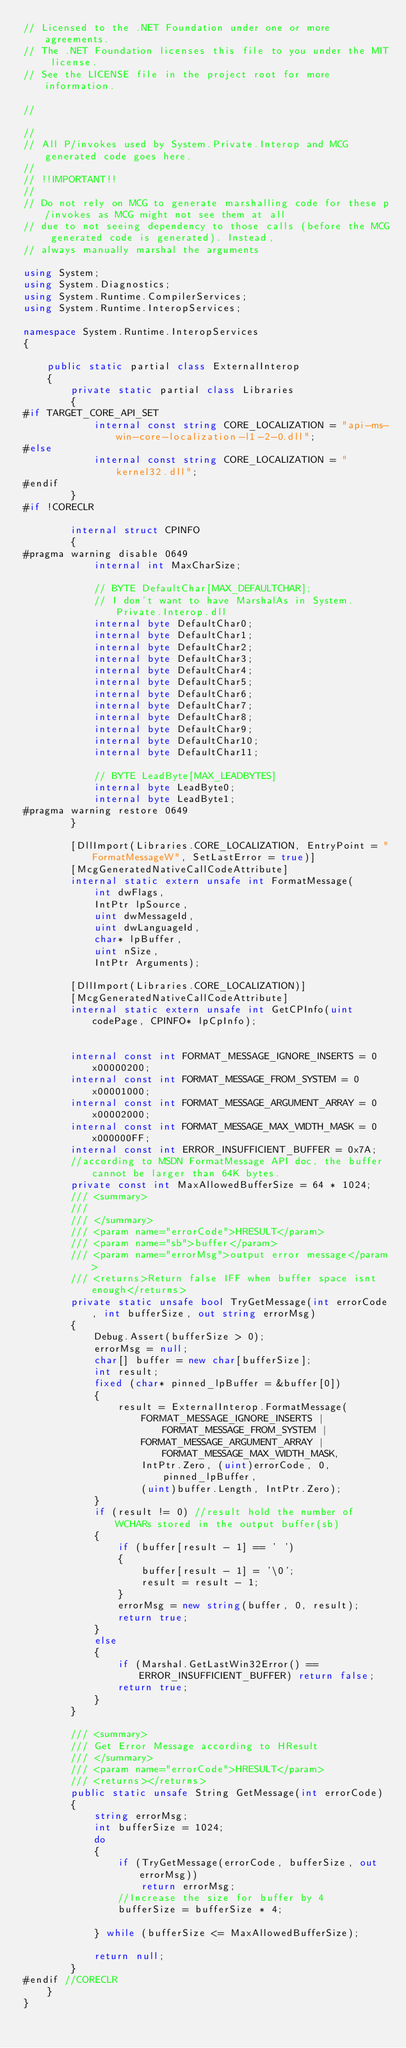Convert code to text. <code><loc_0><loc_0><loc_500><loc_500><_C#_>// Licensed to the .NET Foundation under one or more agreements.
// The .NET Foundation licenses this file to you under the MIT license.
// See the LICENSE file in the project root for more information.

//

//
// All P/invokes used by System.Private.Interop and MCG generated code goes here.
//
// !!IMPORTANT!!
//
// Do not rely on MCG to generate marshalling code for these p/invokes as MCG might not see them at all
// due to not seeing dependency to those calls (before the MCG generated code is generated). Instead,
// always manually marshal the arguments

using System;
using System.Diagnostics;
using System.Runtime.CompilerServices;
using System.Runtime.InteropServices;

namespace System.Runtime.InteropServices
{

    public static partial class ExternalInterop
    {
        private static partial class Libraries
        {
#if TARGET_CORE_API_SET
            internal const string CORE_LOCALIZATION = "api-ms-win-core-localization-l1-2-0.dll";
#else
            internal const string CORE_LOCALIZATION = "kernel32.dll";
#endif
        }
#if !CORECLR

        internal struct CPINFO
        {
#pragma warning disable 0649
            internal int MaxCharSize;

            // BYTE DefaultChar[MAX_DEFAULTCHAR];
            // I don't want to have MarshalAs in System.Private.Interop.dll
            internal byte DefaultChar0;
            internal byte DefaultChar1;
            internal byte DefaultChar2;
            internal byte DefaultChar3;
            internal byte DefaultChar4;
            internal byte DefaultChar5;
            internal byte DefaultChar6;
            internal byte DefaultChar7;
            internal byte DefaultChar8;
            internal byte DefaultChar9;
            internal byte DefaultChar10;
            internal byte DefaultChar11;

            // BYTE LeadByte[MAX_LEADBYTES]
            internal byte LeadByte0;
            internal byte LeadByte1;
#pragma warning restore 0649
        }

        [DllImport(Libraries.CORE_LOCALIZATION, EntryPoint = "FormatMessageW", SetLastError = true)]
        [McgGeneratedNativeCallCodeAttribute]
        internal static extern unsafe int FormatMessage(
            int dwFlags,
            IntPtr lpSource,
            uint dwMessageId,
            uint dwLanguageId,
            char* lpBuffer,
            uint nSize,
            IntPtr Arguments);

        [DllImport(Libraries.CORE_LOCALIZATION)]
        [McgGeneratedNativeCallCodeAttribute]
        internal static extern unsafe int GetCPInfo(uint codePage, CPINFO* lpCpInfo);


        internal const int FORMAT_MESSAGE_IGNORE_INSERTS = 0x00000200;
        internal const int FORMAT_MESSAGE_FROM_SYSTEM = 0x00001000;
        internal const int FORMAT_MESSAGE_ARGUMENT_ARRAY = 0x00002000;
        internal const int FORMAT_MESSAGE_MAX_WIDTH_MASK = 0x000000FF;
        internal const int ERROR_INSUFFICIENT_BUFFER = 0x7A;
        //according to MSDN FormatMessage API doc, the buffer cannot be larger than 64K bytes.
        private const int MaxAllowedBufferSize = 64 * 1024;
        /// <summary>
        ///
        /// </summary>
        /// <param name="errorCode">HRESULT</param>
        /// <param name="sb">buffer</param>
        /// <param name="errorMsg">output error message</param>
        /// <returns>Return false IFF when buffer space isnt enough</returns>
        private static unsafe bool TryGetMessage(int errorCode, int bufferSize, out string errorMsg)
        {
            Debug.Assert(bufferSize > 0);
            errorMsg = null;
            char[] buffer = new char[bufferSize];
            int result;
            fixed (char* pinned_lpBuffer = &buffer[0])
            {
                result = ExternalInterop.FormatMessage(
                    FORMAT_MESSAGE_IGNORE_INSERTS | FORMAT_MESSAGE_FROM_SYSTEM |
                    FORMAT_MESSAGE_ARGUMENT_ARRAY | FORMAT_MESSAGE_MAX_WIDTH_MASK,
                    IntPtr.Zero, (uint)errorCode, 0, pinned_lpBuffer,
                    (uint)buffer.Length, IntPtr.Zero);
            }
            if (result != 0) //result hold the number of WCHARs stored in the output buffer(sb)
            {
                if (buffer[result - 1] == ' ')
                {
                    buffer[result - 1] = '\0';
                    result = result - 1;
                }
                errorMsg = new string(buffer, 0, result);
                return true;
            }
            else
            {
                if (Marshal.GetLastWin32Error() == ERROR_INSUFFICIENT_BUFFER) return false;
                return true;
            }
        }

        /// <summary>
        /// Get Error Message according to HResult
        /// </summary>
        /// <param name="errorCode">HRESULT</param>
        /// <returns></returns>
        public static unsafe String GetMessage(int errorCode)
        {
            string errorMsg;
            int bufferSize = 1024;
            do
            {
                if (TryGetMessage(errorCode, bufferSize, out errorMsg))
                    return errorMsg;
                //Increase the size for buffer by 4
                bufferSize = bufferSize * 4;

            } while (bufferSize <= MaxAllowedBufferSize);

            return null;
        }
#endif //CORECLR
    }
}
</code> 